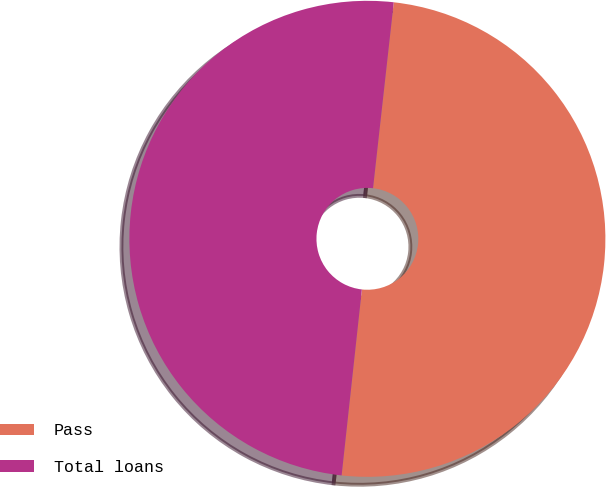<chart> <loc_0><loc_0><loc_500><loc_500><pie_chart><fcel>Pass<fcel>Total loans<nl><fcel>49.96%<fcel>50.04%<nl></chart> 